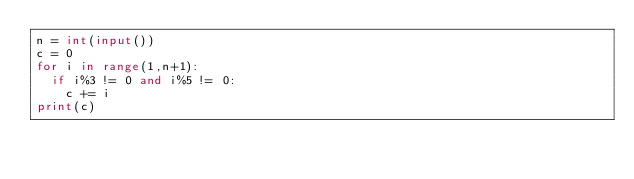<code> <loc_0><loc_0><loc_500><loc_500><_Python_>n = int(input())
c = 0
for i in range(1,n+1):
  if i%3 != 0 and i%5 != 0:
    c += i
print(c)</code> 